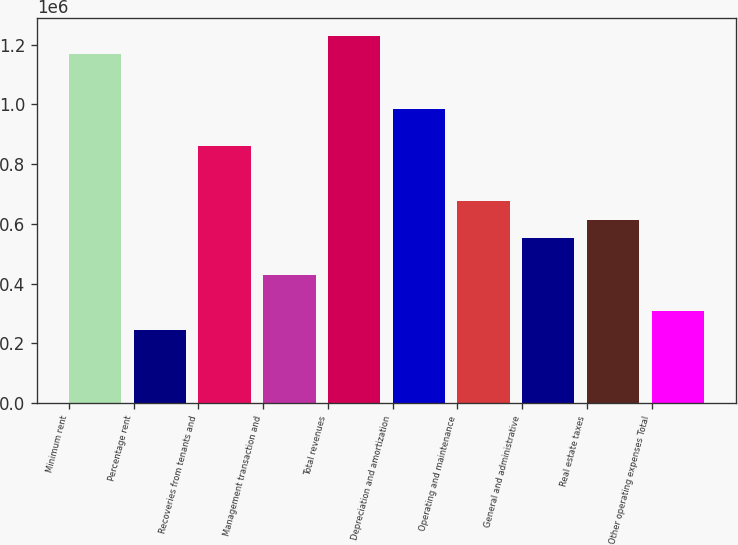Convert chart to OTSL. <chart><loc_0><loc_0><loc_500><loc_500><bar_chart><fcel>Minimum rent<fcel>Percentage rent<fcel>Recoveries from tenants and<fcel>Management transaction and<fcel>Total revenues<fcel>Depreciation and amortization<fcel>Operating and maintenance<fcel>General and administrative<fcel>Real estate taxes<fcel>Other operating expenses Total<nl><fcel>1.1673e+06<fcel>245749<fcel>860119<fcel>430060<fcel>1.22874e+06<fcel>982993<fcel>675808<fcel>552934<fcel>614371<fcel>307186<nl></chart> 